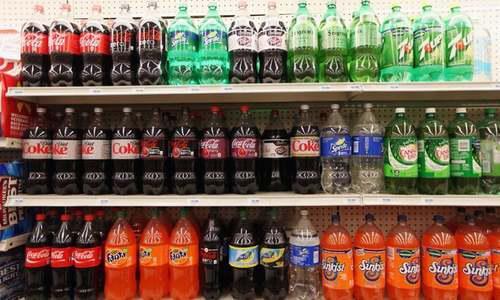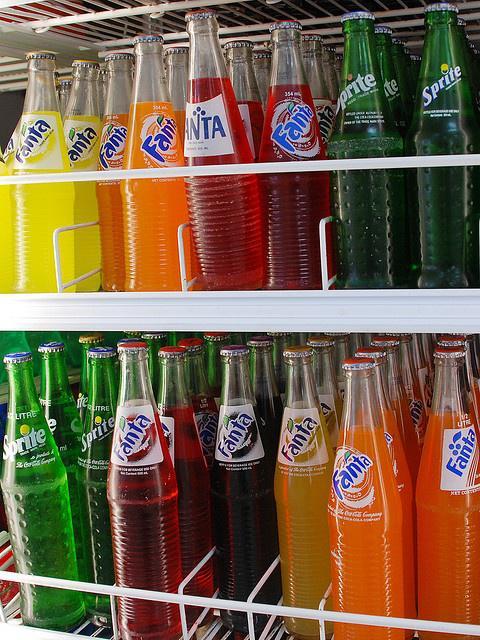The first image is the image on the left, the second image is the image on the right. For the images shown, is this caption "All the bottles are full." true? Answer yes or no. Yes. The first image is the image on the left, the second image is the image on the right. Assess this claim about the two images: "Some of the soda bottles are in plastic crates.". Correct or not? Answer yes or no. No. 